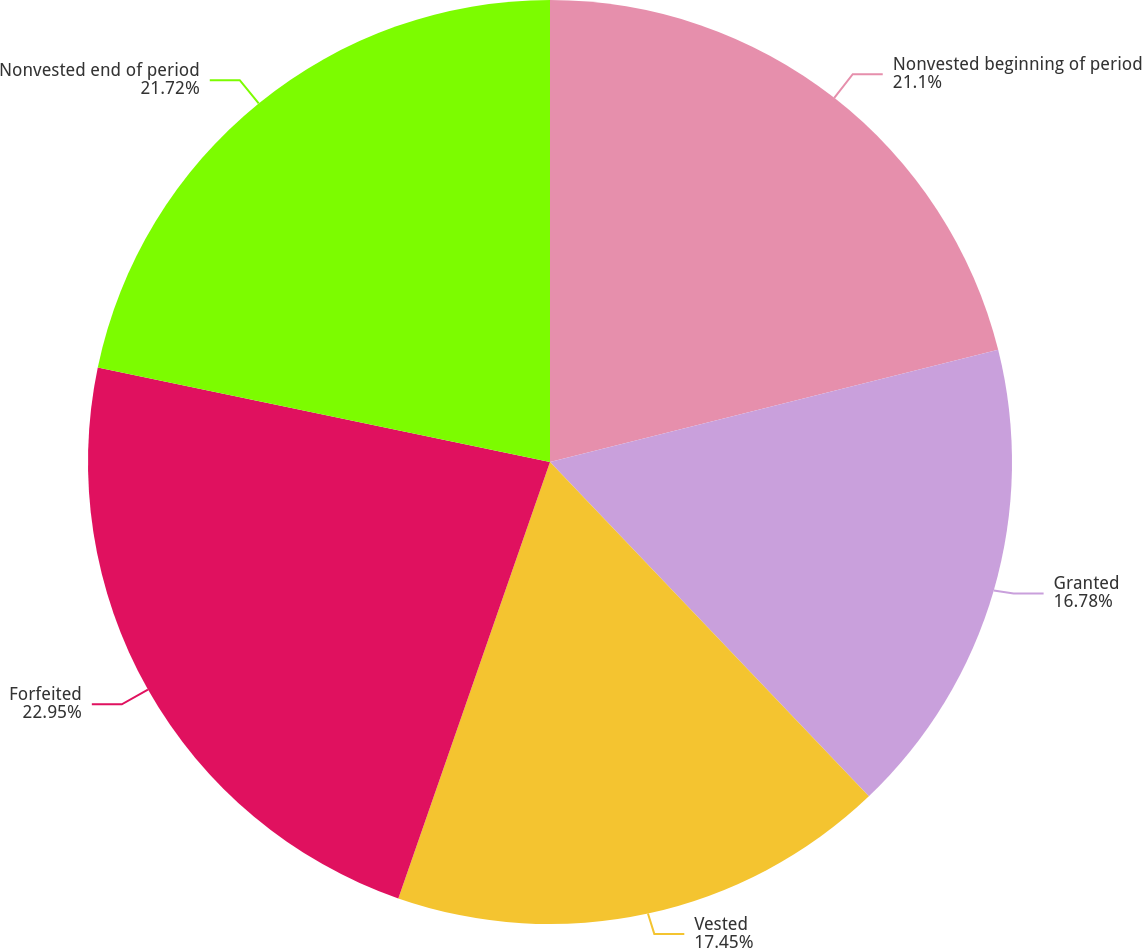Convert chart to OTSL. <chart><loc_0><loc_0><loc_500><loc_500><pie_chart><fcel>Nonvested beginning of period<fcel>Granted<fcel>Vested<fcel>Forfeited<fcel>Nonvested end of period<nl><fcel>21.1%<fcel>16.78%<fcel>17.45%<fcel>22.96%<fcel>21.72%<nl></chart> 